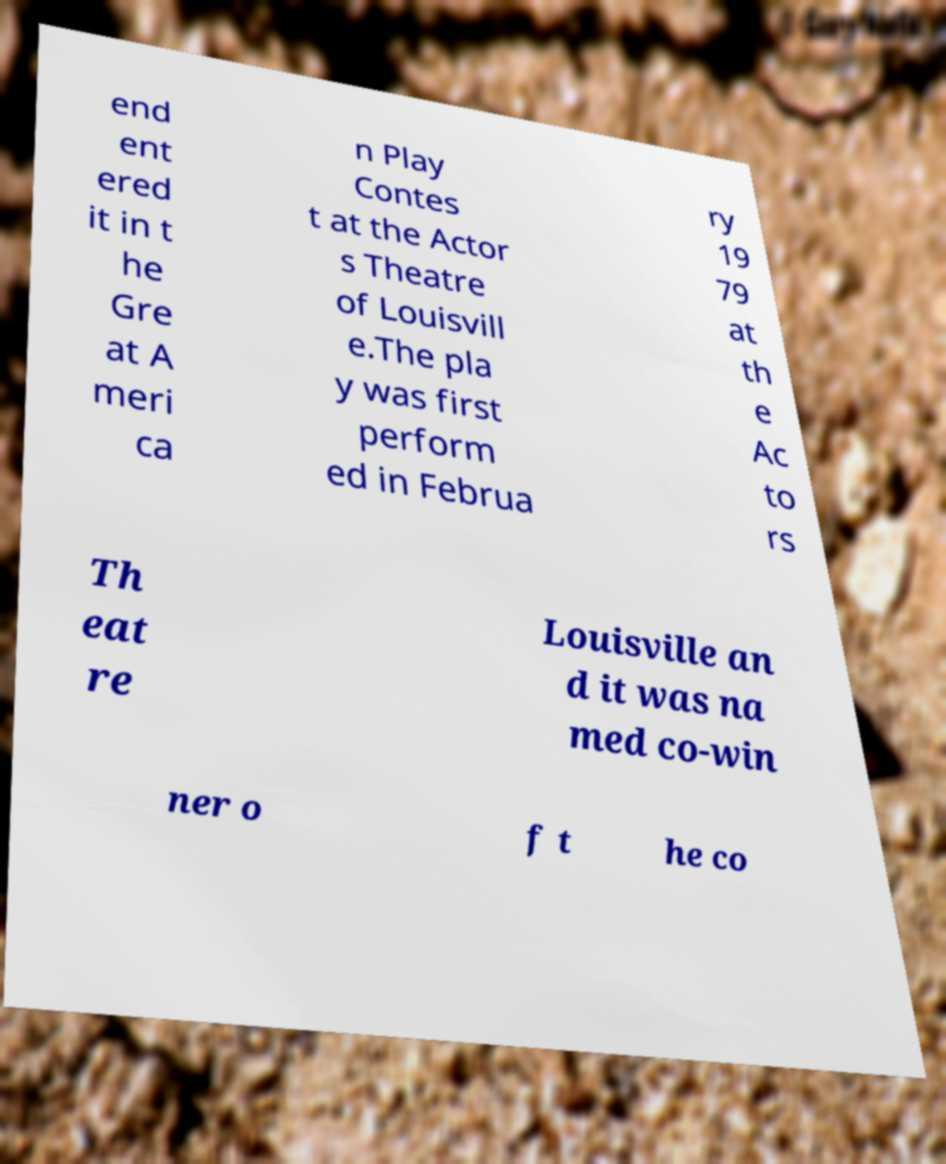What messages or text are displayed in this image? I need them in a readable, typed format. end ent ered it in t he Gre at A meri ca n Play Contes t at the Actor s Theatre of Louisvill e.The pla y was first perform ed in Februa ry 19 79 at th e Ac to rs Th eat re Louisville an d it was na med co-win ner o f t he co 